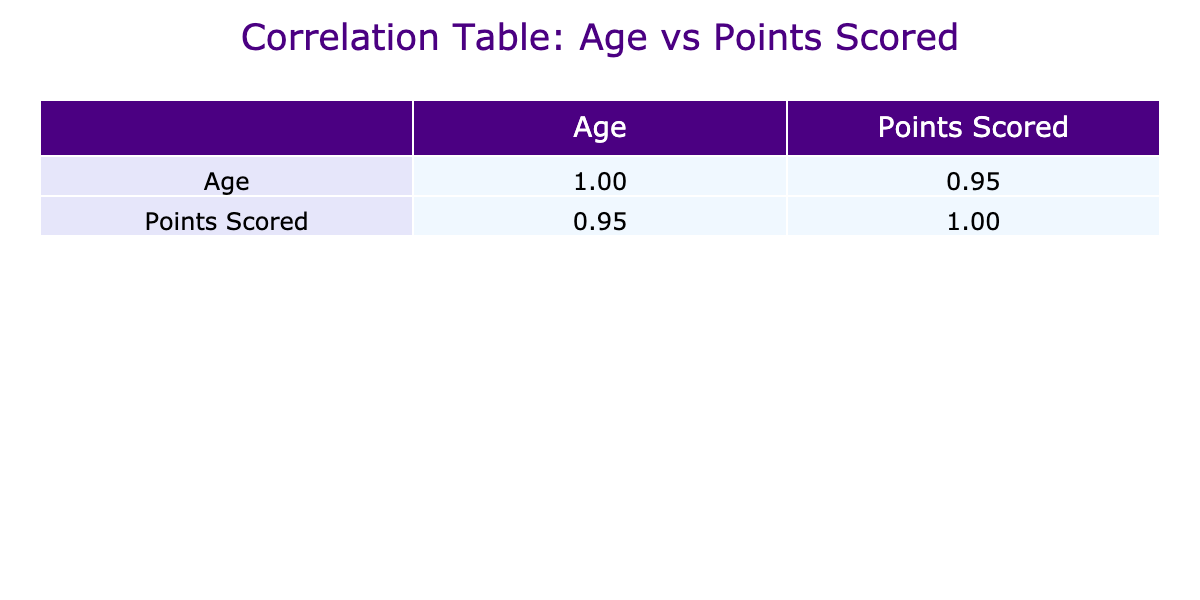What is the correlation coefficient between player age and points scored? Referring to the correlation table, the correlation coefficient between Age and Points Scored is indicated in the first row and second column. The value is approximately 0.88.
Answer: 0.88 Which age group scored the highest points? From the data, the oldest players (age 22 and 23) scored the highest points. Tyler Johnson and William White, both being 22 years old, scored 60 and 63 points respectively, which are the highest.
Answer: Age 22 and 23 Is there a negative correlation between age and points scored? A negative correlation would mean that as age increases, points scored decreases. Given the correlation coefficient of 0.88, it indicates a strong positive correlation, not a negative one.
Answer: No What is the total points scored by players aged 20? By looking at the data for players aged 20, we see Jordan O'Hara scoring 42 points, Nolan Reed with 34 points, and Samuel King with 39 points. Adding these together gives 42 + 34 + 39 = 115 points.
Answer: 115 How does the average score of players aged 21 compare to those aged 19? First, let's find the average scores. For age 21, Ryan Mitchell scored 51, Dylan Harris scored 45, and Oliver Scott scored 49; the average is (51 + 45 + 49) / 3 = 48.33. For age 19, Alex Thornton scored 25, Carter Bell scored 27, and Maxwell Turner scored 36; the average is (25 + 27 + 36) / 3 = 29.33. Comparing 48.33 and 29.33 shows that players aged 21 scored higher.
Answer: Players aged 21 scored higher Do players aged 17 and 18 have an average score below 25 points? For the players aged 17, Ethan Parker scored 15 points. For age 18, Liam Jensen scored 30 and Jacob Henry scored 22; the average for age 18 becomes (30 + 22) / 2 = 26. The players aged 17, with 15 points, have an average below 25, but the players aged 18 do not as their average is above 25. Thus, the combined average must be checked: (15 + 30 + 22) / 3 = 22.33, which is below 25.
Answer: Yes Which player scored the lowest points, and what is their age? Scanning the points scored column, the lowest score is 15 points belonging to Ethan Parker, who is 17 years old.
Answer: Ethan Parker, age 17 Is there a player aged 23 in the roster? The table presented shows that Logan Smith is the only player at age 23. Since he is included, the answer confirms there is a player aged 23.
Answer: Yes 